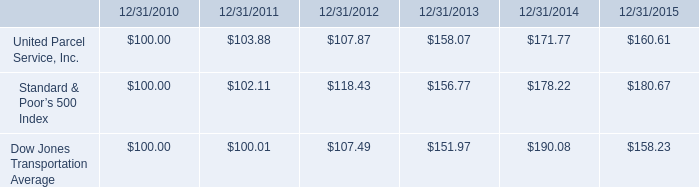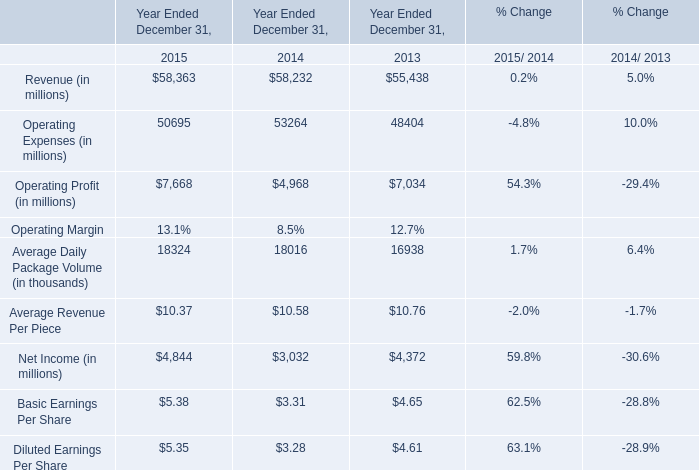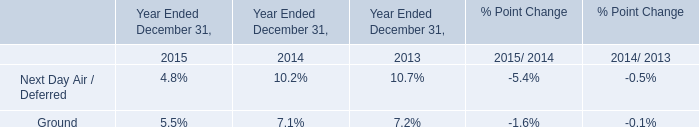In the year with lowest amount of Operating Profit (in millions), what's the increasing rate of Operating Expenses (in millions? (in %) 
Computations: ((53264 - 48404) / 48404)
Answer: 0.1004. 